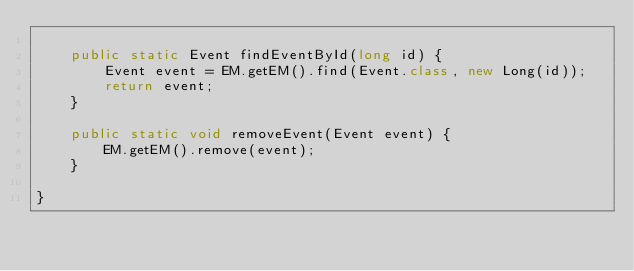Convert code to text. <code><loc_0><loc_0><loc_500><loc_500><_Java_>
	public static Event findEventById(long id) {
		Event event = EM.getEM().find(Event.class, new Long(id));
		return event;
	}

	public static void removeEvent(Event event) {
		EM.getEM().remove(event);
	}

}
</code> 